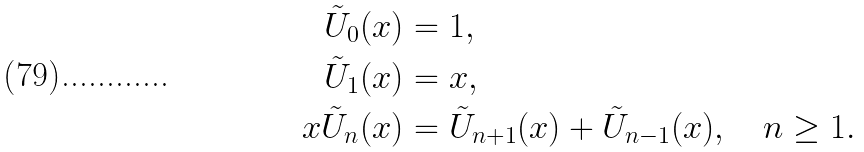<formula> <loc_0><loc_0><loc_500><loc_500>\tilde { U } _ { 0 } ( x ) & = 1 , \\ \tilde { U } _ { 1 } ( x ) & = x , \\ x \tilde { U } _ { n } ( x ) & = \tilde { U } _ { n + 1 } ( x ) + \tilde { U } _ { n - 1 } ( x ) , \quad n \geq 1 .</formula> 